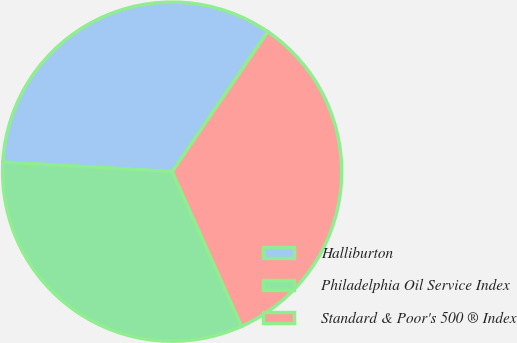Convert chart to OTSL. <chart><loc_0><loc_0><loc_500><loc_500><pie_chart><fcel>Halliburton<fcel>Philadelphia Oil Service Index<fcel>Standard & Poor's 500 ® Index<nl><fcel>33.64%<fcel>32.61%<fcel>33.75%<nl></chart> 